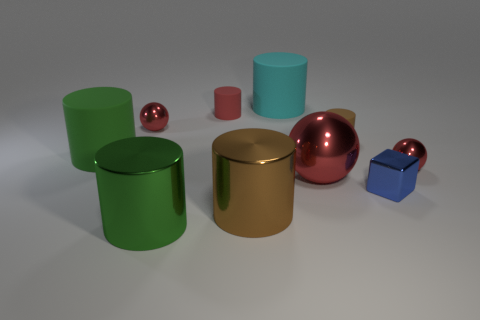Subtract all tiny metal balls. How many balls are left? 1 Subtract all cyan cylinders. How many cylinders are left? 5 Subtract all cylinders. How many objects are left? 4 Subtract 1 cylinders. How many cylinders are left? 5 Subtract all cyan blocks. Subtract all gray balls. How many blocks are left? 1 Subtract all red balls. How many green cylinders are left? 2 Subtract all tiny cyan objects. Subtract all shiny cylinders. How many objects are left? 8 Add 8 red matte cylinders. How many red matte cylinders are left? 9 Add 6 spheres. How many spheres exist? 9 Subtract 0 green spheres. How many objects are left? 10 